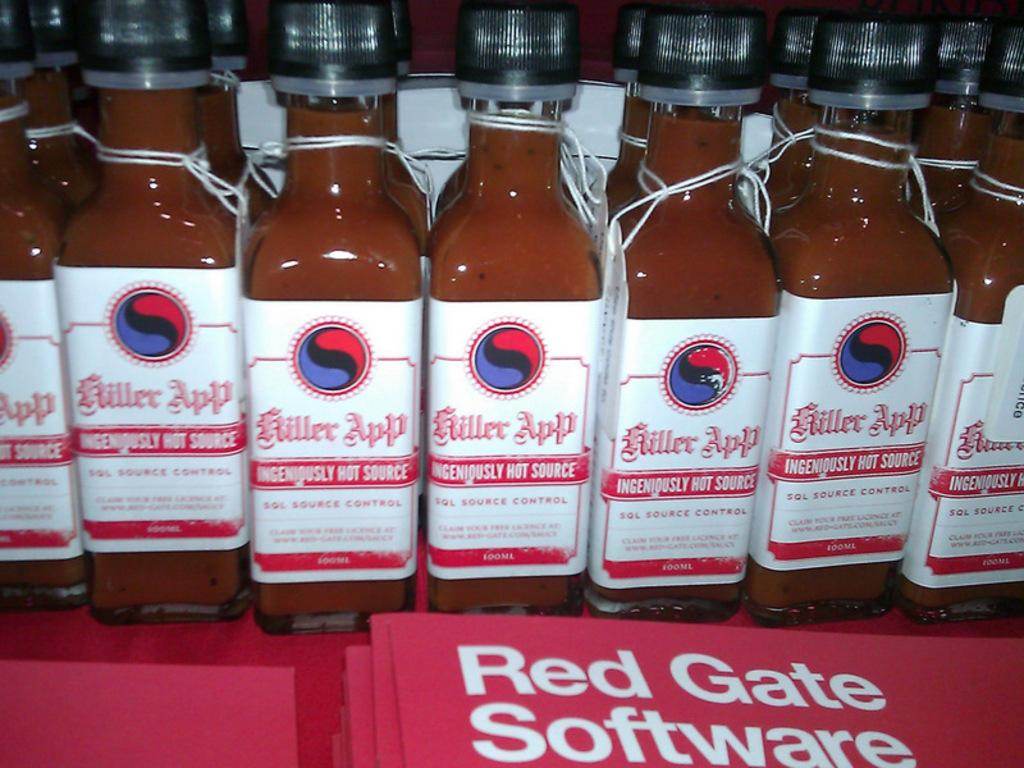Provide a one-sentence caption for the provided image. Several unopened bottles of Miller App hot sauce sit before red folders with the words Red Gate Software on them. 